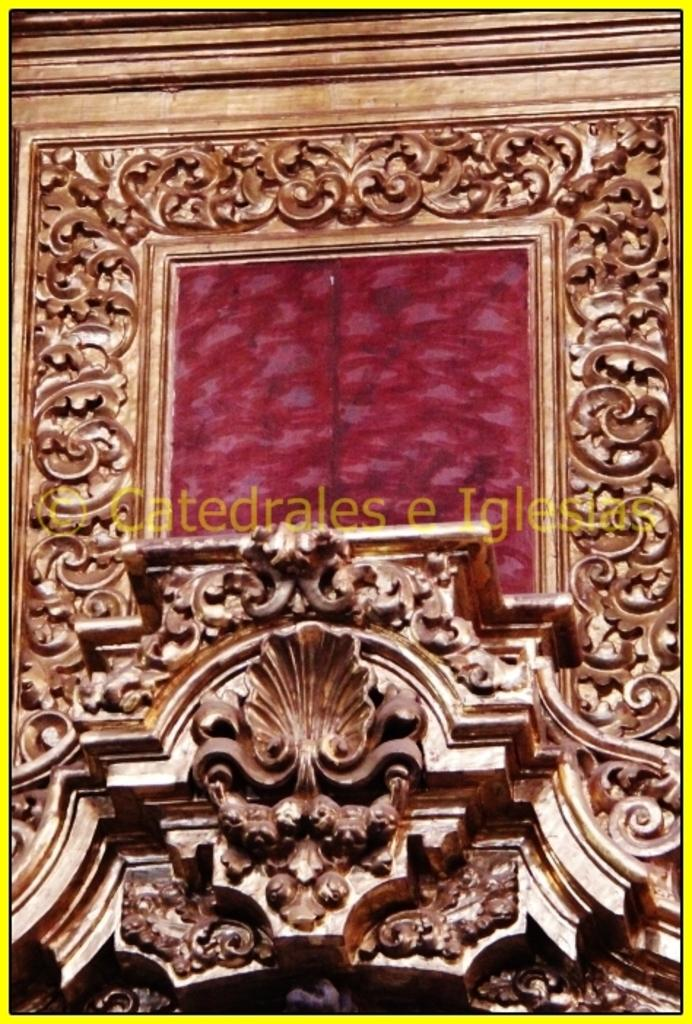<image>
Relay a brief, clear account of the picture shown. A photo with a watermark that says catedrales e Iglesia on it. 